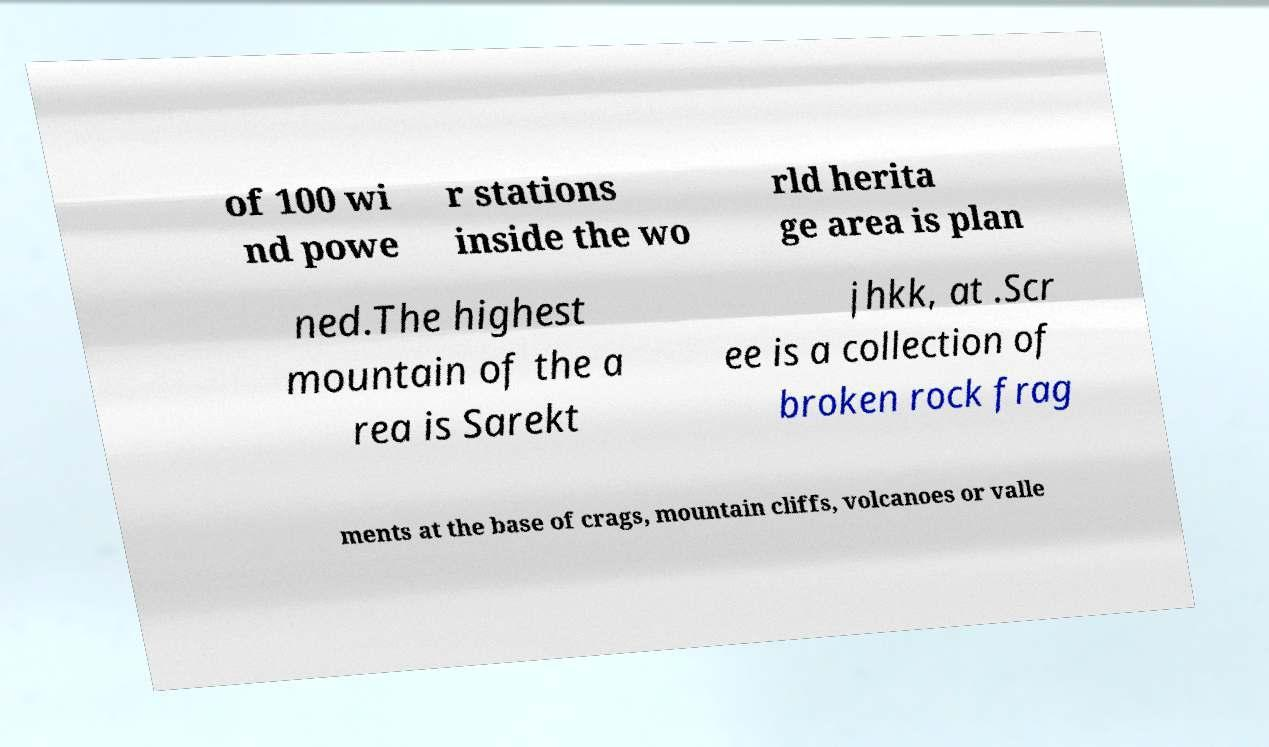Please read and relay the text visible in this image. What does it say? of 100 wi nd powe r stations inside the wo rld herita ge area is plan ned.The highest mountain of the a rea is Sarekt jhkk, at .Scr ee is a collection of broken rock frag ments at the base of crags, mountain cliffs, volcanoes or valle 